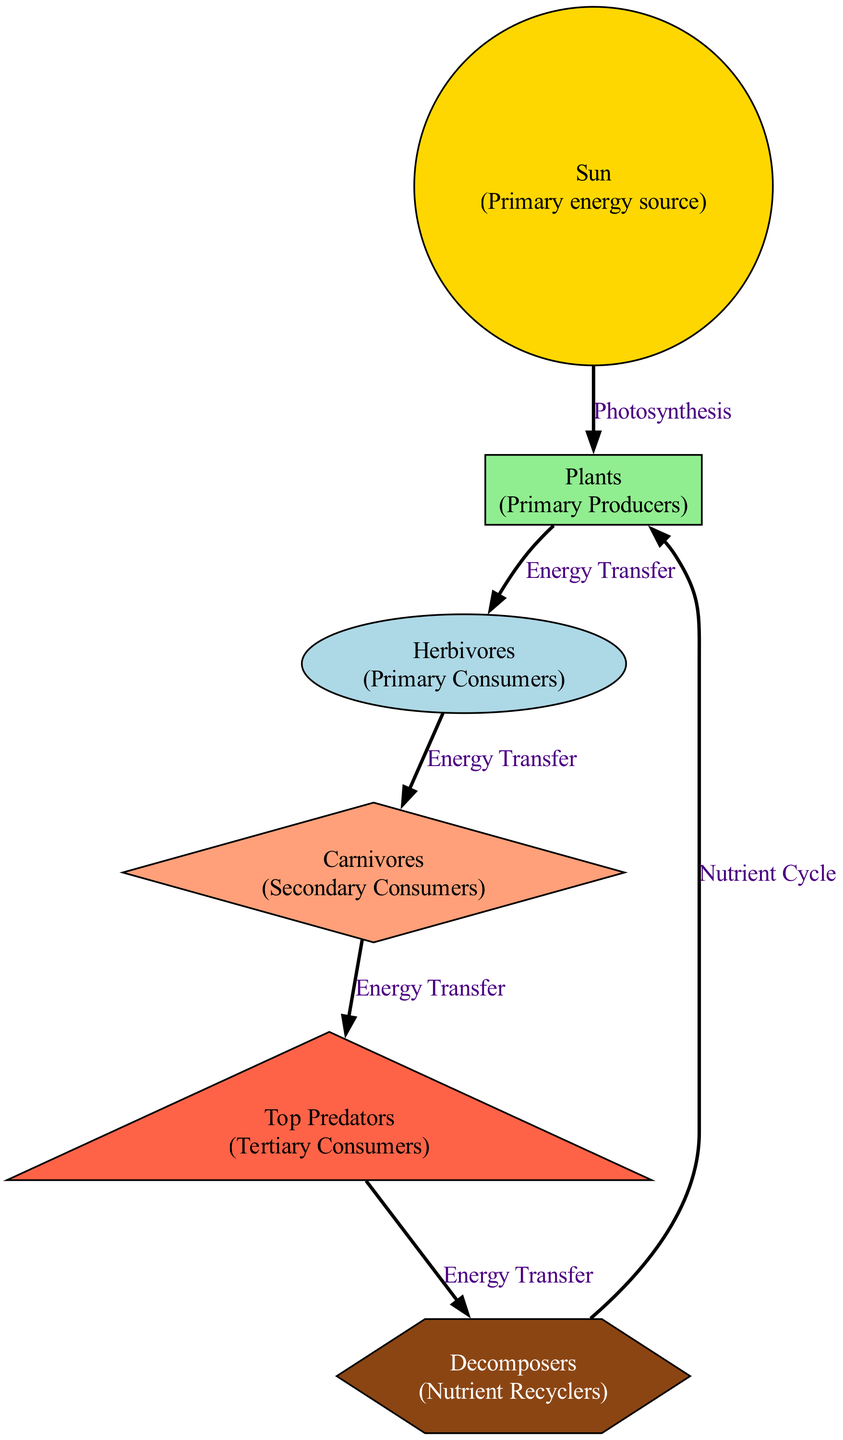What is the primary energy source in this ecosystem? According to the diagram, the primary energy source is labeled as "Sun." It is the starting point of the food chain and provides the energy needed for photosynthesis in plants.
Answer: Sun How many nodes are present in the diagram? By counting all the distinct entities depicted in the diagram, we find there are six nodes: Sun, Plants, Herbivores, Carnivores, Top Predators, and Decomposers.
Answer: 6 What is the role of herbivores in this ecosystem? The diagram indicates that herbivores are classified as "Primary Consumers," which means they directly consume the energy sourced from "Plants." This role is crucial for energy transfer in the food chain.
Answer: Primary Consumers Which node receives energy directly from decomposers? The edge from "Decomposers" points to "Plants," indicating that the energy is transferred back to plants, showcasing the nutrient recycling process.
Answer: Plants How does energy transfer occur from carnivores to top predators? The connection between "Carnivores" and "Top Predators" is noted as "Energy Transfer," showing that top predators obtain their energy by consuming carnivores in the food chain progression.
Answer: Energy Transfer What shape represents the decomposers in the diagram? According to the diagram's node styles, "Decomposers" are represented with a hexagon shape. This specific shape visually distinguishes it from other levels of the food chain.
Answer: Hexagon What describes the relationship between the sun and the plants? The relationship is indicated as "Photosynthesis," pointing out that plants utilize sunlight to convert energy through the process of photosynthesis, forming the foundation of the food chain.
Answer: Photosynthesis Which trophic level is referred to as tertiary consumers? The "Top Predators" node is labeled as the tertiary consumers, illustrating their position at the highest level of the food chain, where they depend on carnivores for energy.
Answer: Top Predators What role do decomposers play in the energy cycle? Decomposers are essential as "Nutrient Recyclers," highlighting their function in breaking down organic matter and returning essential nutrients to the ecosystem, thereby completing the energy cycle.
Answer: Nutrient Recyclers 